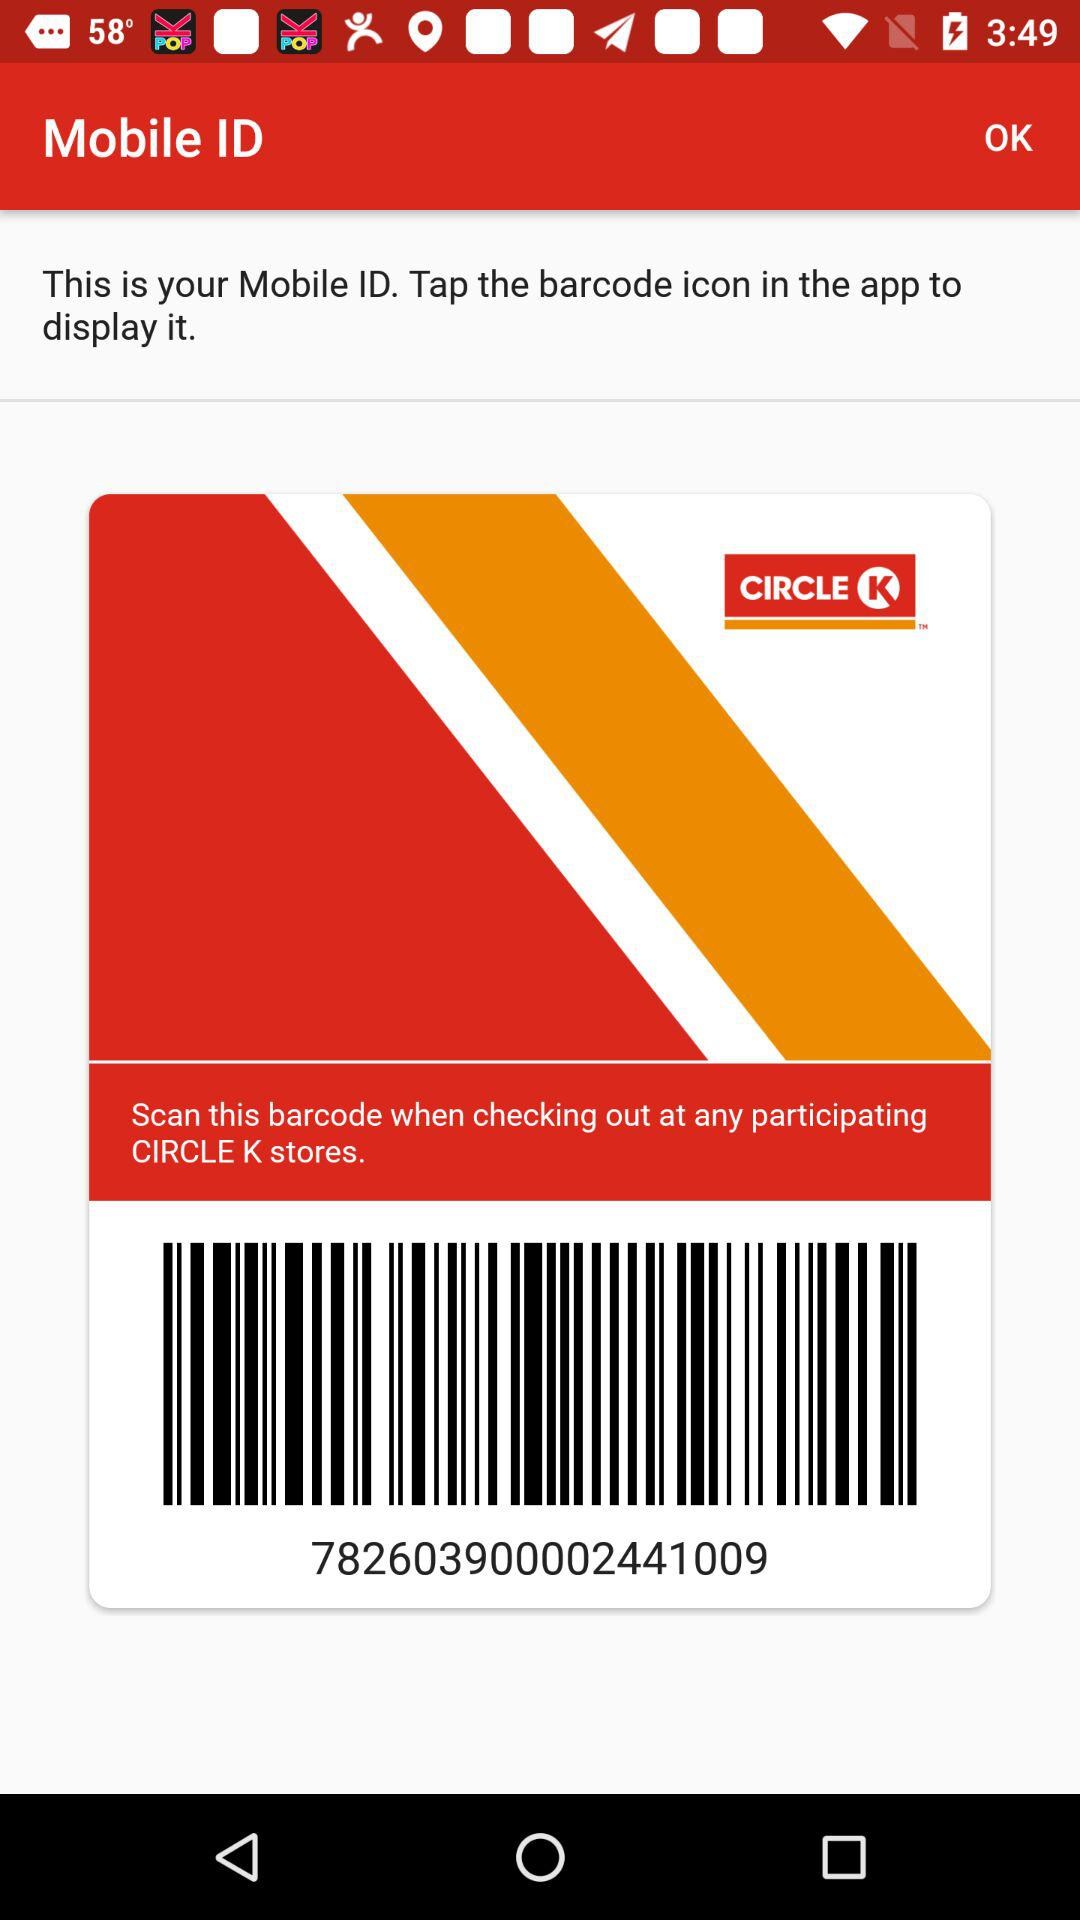What is the barcode number? The barcode number is 782603900002441009. 